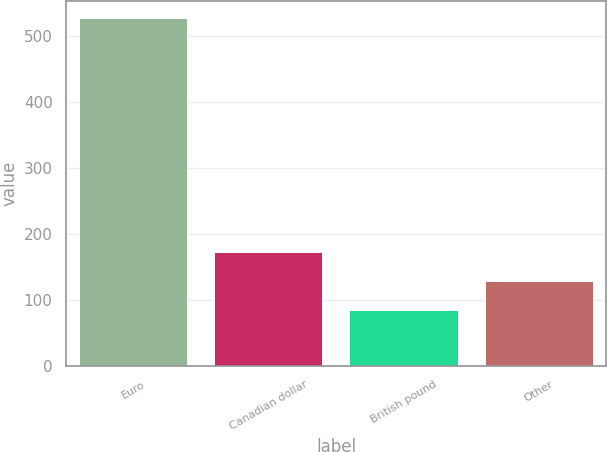Convert chart. <chart><loc_0><loc_0><loc_500><loc_500><bar_chart><fcel>Euro<fcel>Canadian dollar<fcel>British pound<fcel>Other<nl><fcel>527.3<fcel>173.3<fcel>84.8<fcel>129.05<nl></chart> 